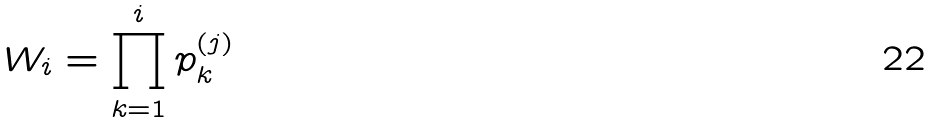Convert formula to latex. <formula><loc_0><loc_0><loc_500><loc_500>W _ { i } = \prod _ { k = 1 } ^ { i } p _ { k } ^ { ( j ) }</formula> 